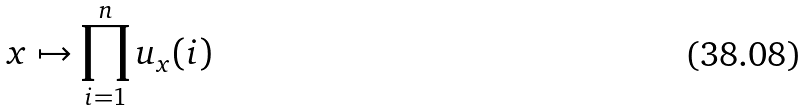Convert formula to latex. <formula><loc_0><loc_0><loc_500><loc_500>x \mapsto \prod _ { i = 1 } ^ { n } u _ { x } ( i )</formula> 